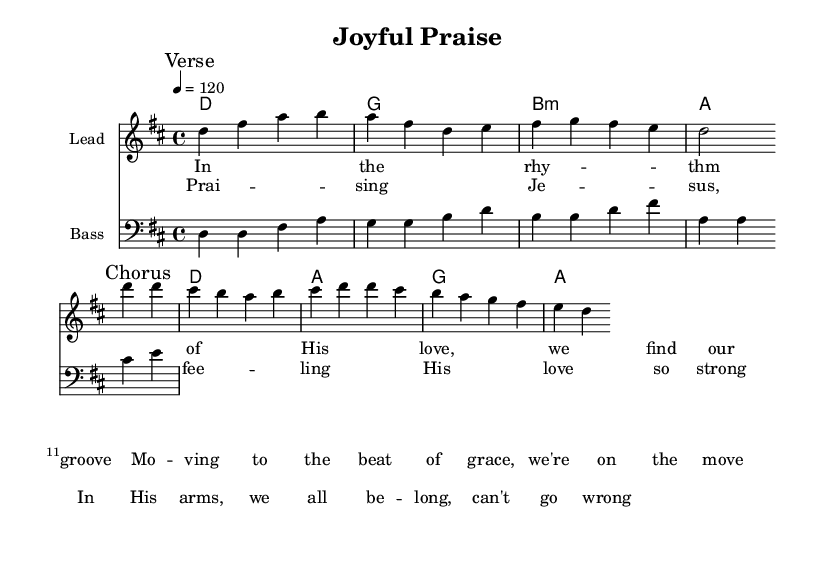What is the key signature of this music? The key signature is two sharps, which indicates that the key is D major. This can be identified by looking at the key signature notation at the beginning of the sheet music.
Answer: D major What is the time signature of this music? The time signature is 4/4, indicated at the beginning of the piece. This means there are four beats in each measure, and a quarter note gets one beat.
Answer: 4/4 What is the tempo marking for this piece? The tempo marking indicates a speed of 120 beats per minute, shown as "4 = 120" in the tempo indication. This tells the performers how fast to play the music.
Answer: 120 Which section of the song has the lyrics "Prai -- sing Je -- sus"? This lyric is in the Chorus section, which is marked clearly in the sheet music. The lyrics are written directly under the corresponding melody notes.
Answer: Chorus What chords are used in the first measure? The chords in the first measure are D major and G major, as shown in the chord section at the beginning of the score. Each chord corresponds to the top line of the music and is played alongside the melody.
Answer: D, G How many measures are there in the verse? The verse consists of 4 measures, as indicated by the notation for the verse section and the separation of each measure in the sheet music. Each measure is counted based on beat divisions.
Answer: 4 What genre does this piece belong to? This piece is classified as Gospel-inspired funk music due to its uplifting Christian lyrics and rhythmic style, characteristic of the funk genre. This genre typically combines elements of funk with themes of spirituality or religious expression.
Answer: Gospel funk 